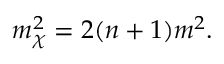<formula> <loc_0><loc_0><loc_500><loc_500>m _ { \chi } ^ { 2 } = 2 ( n + 1 ) m ^ { 2 } .</formula> 